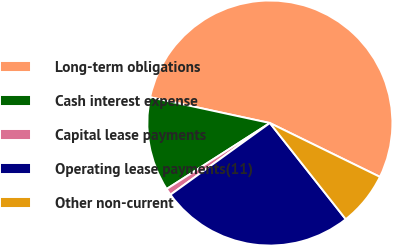<chart> <loc_0><loc_0><loc_500><loc_500><pie_chart><fcel>Long-term obligations<fcel>Cash interest expense<fcel>Capital lease payments<fcel>Operating lease payments(11)<fcel>Other non-current<nl><fcel>53.87%<fcel>12.43%<fcel>0.89%<fcel>25.69%<fcel>7.13%<nl></chart> 